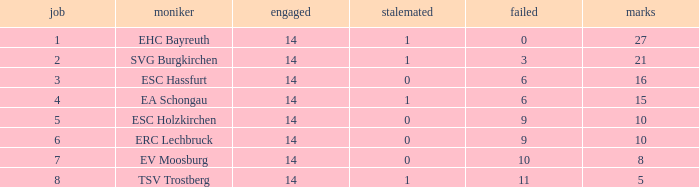What's the most points for Ea Schongau with more than 1 drawn? None. 